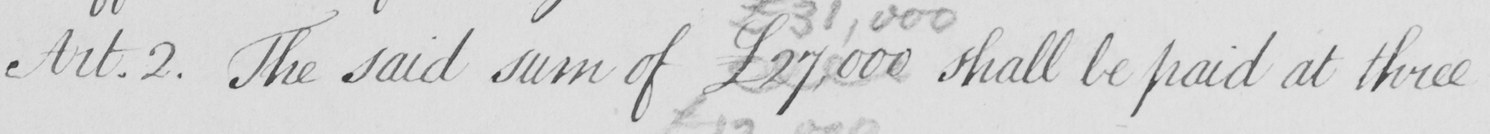Transcribe the text shown in this historical manuscript line. Art . 2 .  The said sum of £27,000  shall be paid at three 